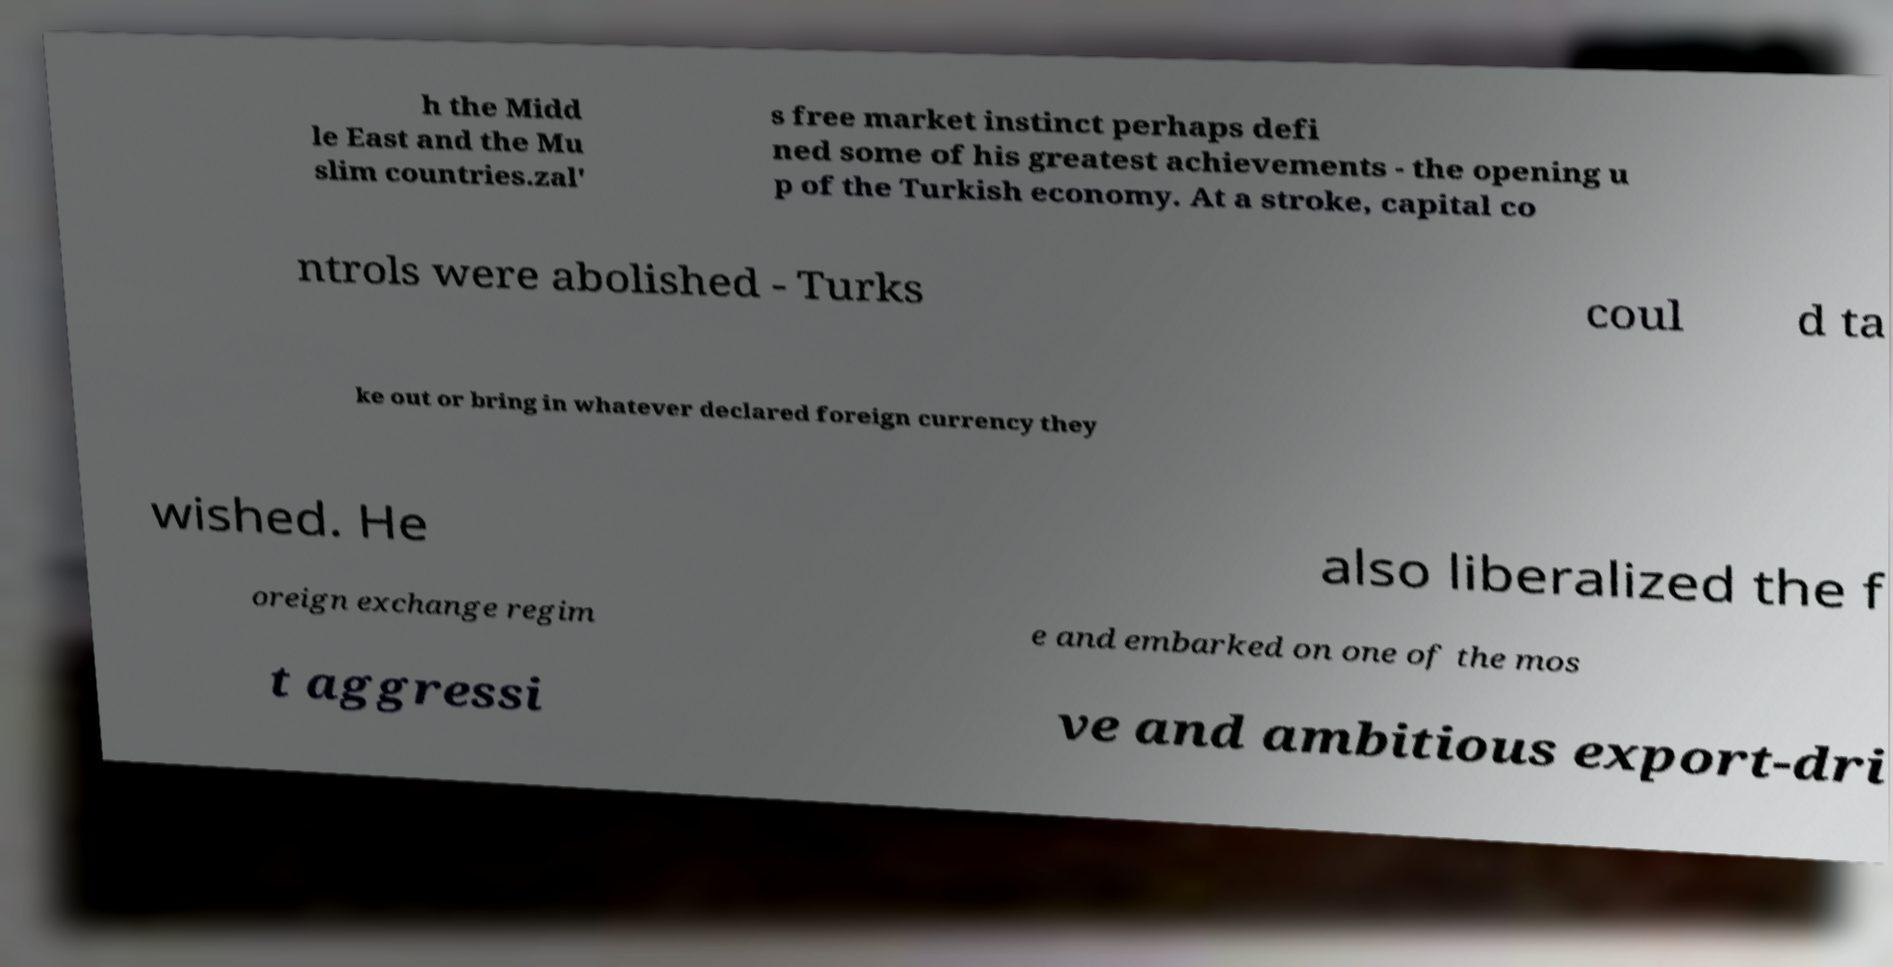What messages or text are displayed in this image? I need them in a readable, typed format. h the Midd le East and the Mu slim countries.zal' s free market instinct perhaps defi ned some of his greatest achievements - the opening u p of the Turkish economy. At a stroke, capital co ntrols were abolished - Turks coul d ta ke out or bring in whatever declared foreign currency they wished. He also liberalized the f oreign exchange regim e and embarked on one of the mos t aggressi ve and ambitious export-dri 